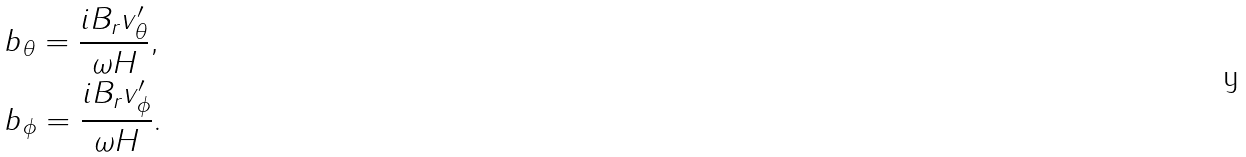<formula> <loc_0><loc_0><loc_500><loc_500>& b _ { \theta } = \frac { i B _ { r } v ^ { \prime } _ { \theta } } { \omega H } , \\ & b _ { \phi } = \frac { i B _ { r } v ^ { \prime } _ { \phi } } { \omega H } . \\</formula> 